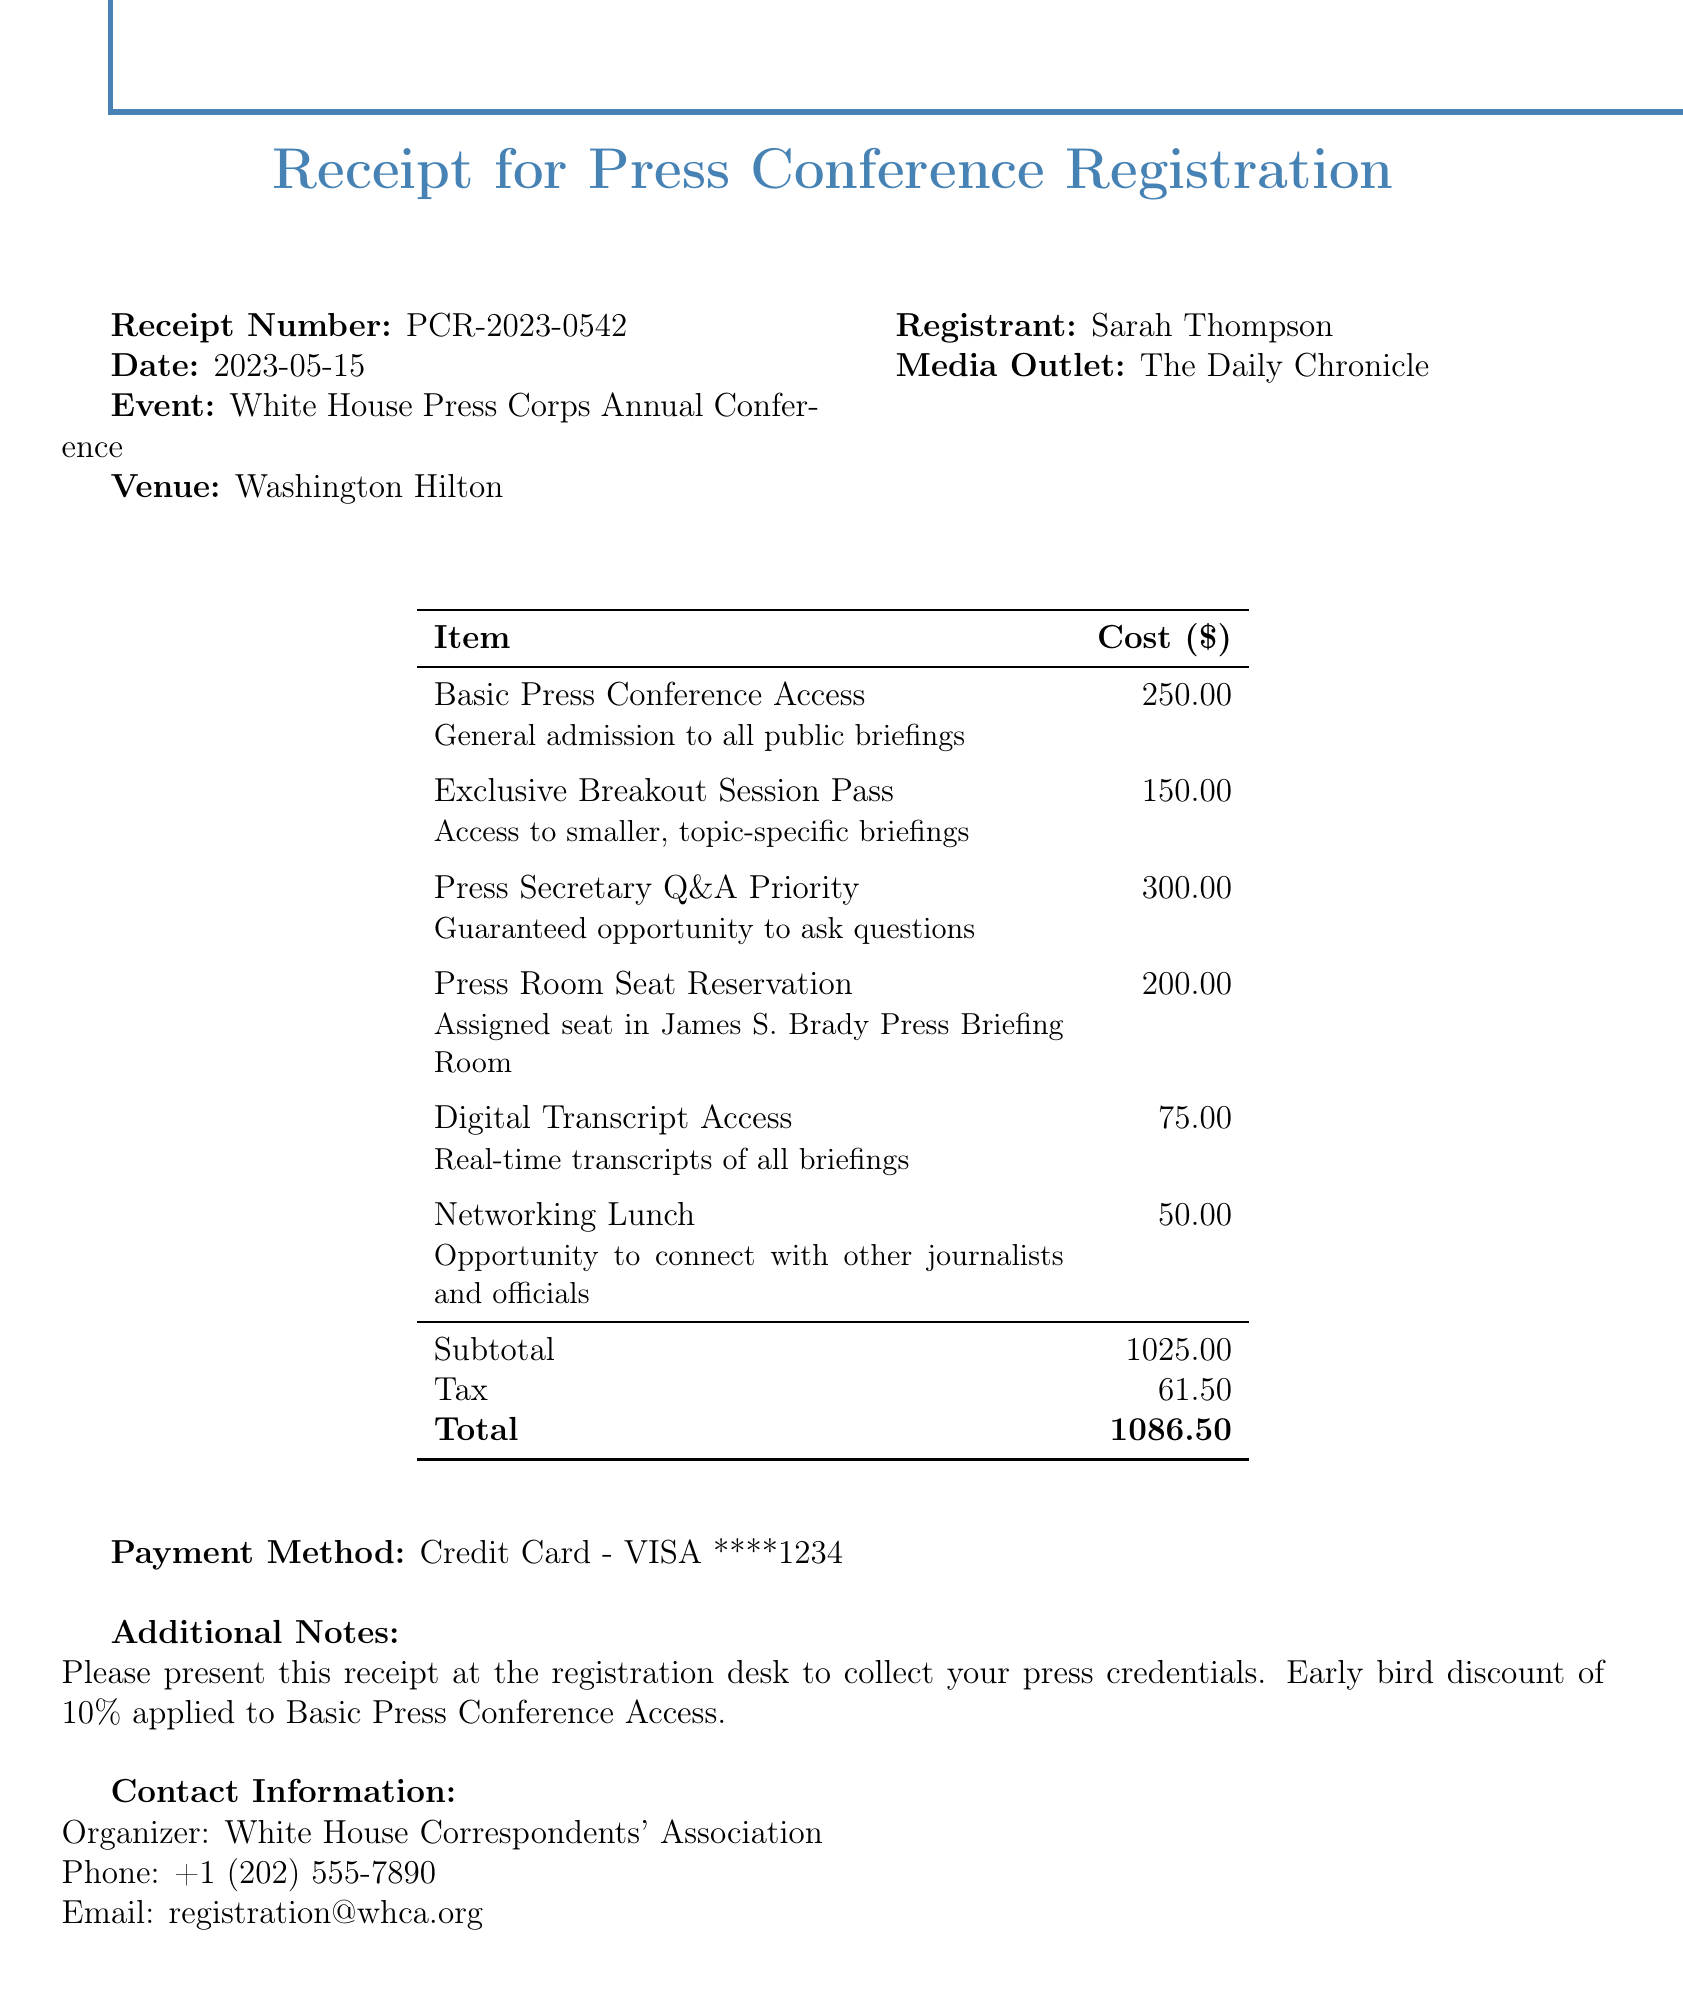What is the receipt number? The receipt number is specified at the top of the document for identification purposes.
Answer: PCR-2023-0542 What is the total cost for registration? The total cost is calculated as the sum of all itemized costs, taxes, etc.
Answer: 1086.50 Who is the registrant for the conference? The registrant's name is mentioned prominently in the receipt.
Answer: Sarah Thompson What method was used for payment? The payment method is mentioned in the receipt to provide details of the transaction.
Answer: Credit Card - VISA ****1234 How much does the Basic Press Conference Access cost? The cost for the Basic Press Conference Access is listed in the itemized costs section.
Answer: 250.00 What is included in the Exclusive Breakout Session Pass? The description for the Exclusive Breakout Session Pass provides information on what it includes.
Answer: Access to smaller, topic-specific briefings What is the subtotal before tax? The subtotal is detailed before the tax is applied for clarity on the costs.
Answer: 1025.00 What additional notes are provided? Additional notes include important instructions for the registrant related to their registration.
Answer: Please present this receipt at the registration desk to collect your press credentials. Early bird discount of 10% applied to Basic Press Conference Access 